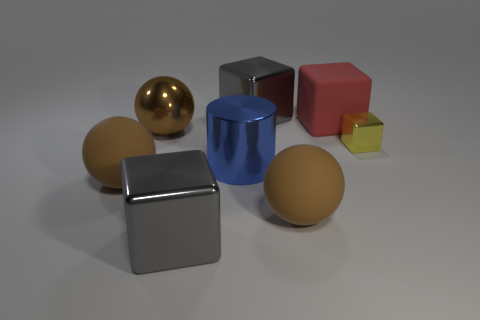What could be the purpose of these objects? These objects seem to be 3D models, quite possibly used for a rendering test or to demonstrate various shading and lighting techniques in computer graphics. They display how different shapes and materials interact with a light source, providing a simple yet effective method for showcasing rendering capabilities. 